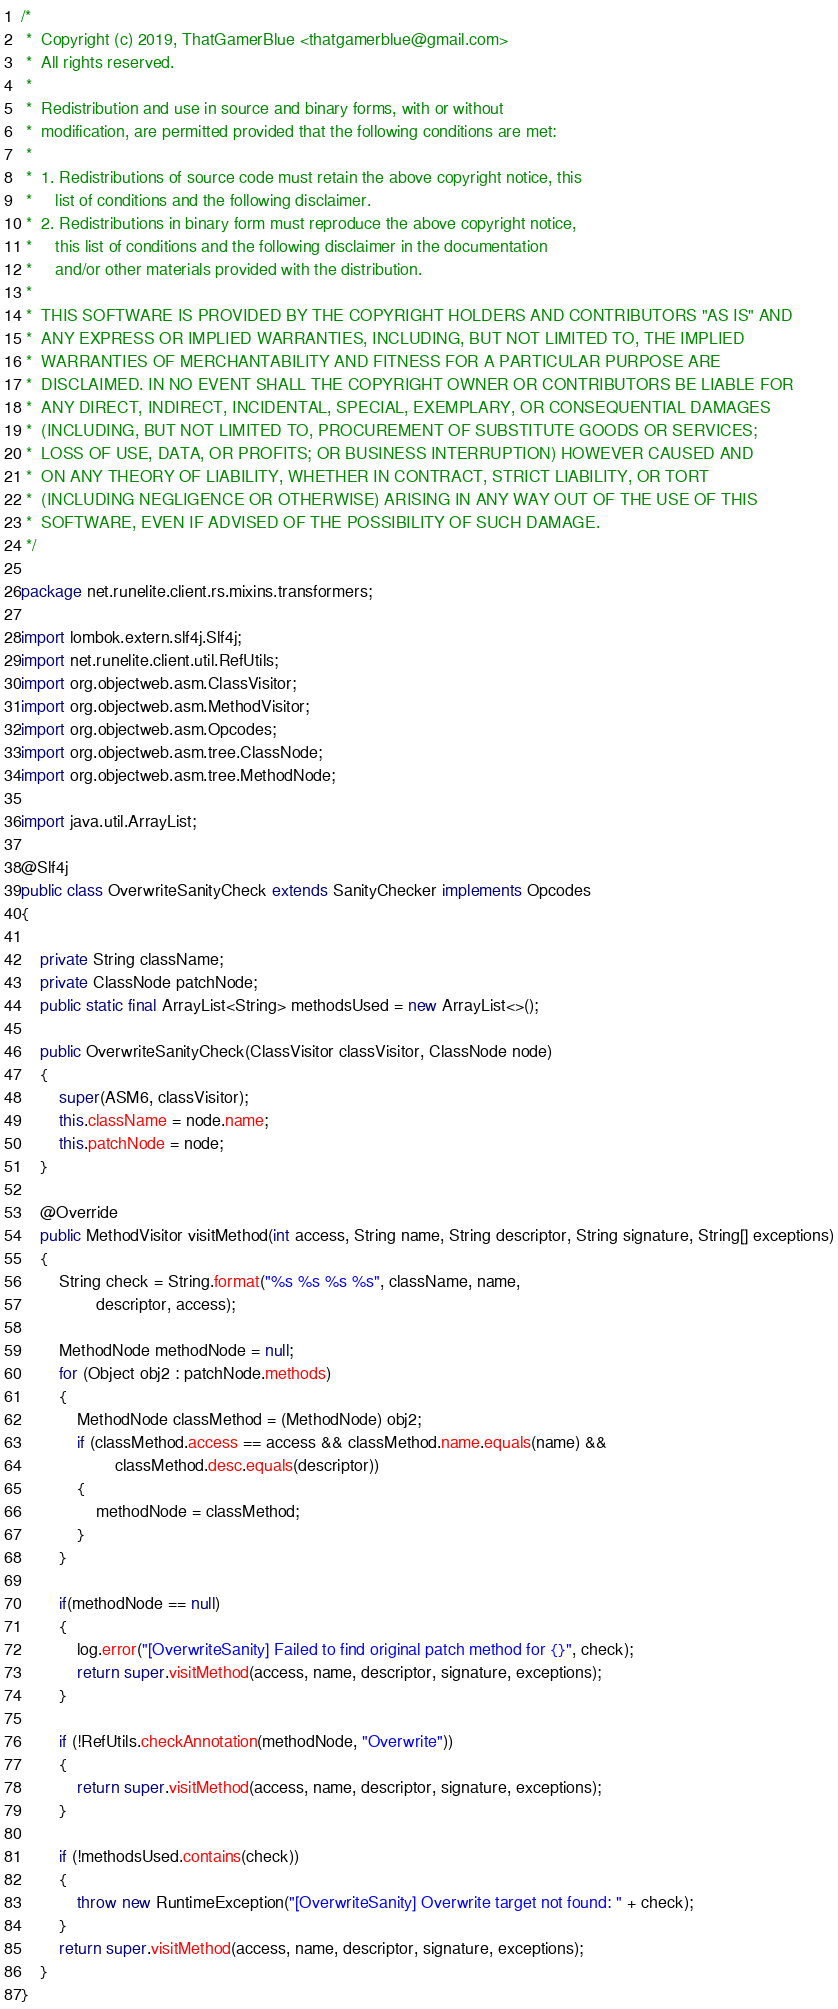Convert code to text. <code><loc_0><loc_0><loc_500><loc_500><_Java_>/*
 *  Copyright (c) 2019, ThatGamerBlue <thatgamerblue@gmail.com>
 *  All rights reserved.
 *
 *  Redistribution and use in source and binary forms, with or without
 *  modification, are permitted provided that the following conditions are met:
 *
 *  1. Redistributions of source code must retain the above copyright notice, this
 *     list of conditions and the following disclaimer.
 *  2. Redistributions in binary form must reproduce the above copyright notice,
 *     this list of conditions and the following disclaimer in the documentation
 *     and/or other materials provided with the distribution.
 *
 *  THIS SOFTWARE IS PROVIDED BY THE COPYRIGHT HOLDERS AND CONTRIBUTORS "AS IS" AND
 *  ANY EXPRESS OR IMPLIED WARRANTIES, INCLUDING, BUT NOT LIMITED TO, THE IMPLIED
 *  WARRANTIES OF MERCHANTABILITY AND FITNESS FOR A PARTICULAR PURPOSE ARE
 *  DISCLAIMED. IN NO EVENT SHALL THE COPYRIGHT OWNER OR CONTRIBUTORS BE LIABLE FOR
 *  ANY DIRECT, INDIRECT, INCIDENTAL, SPECIAL, EXEMPLARY, OR CONSEQUENTIAL DAMAGES
 *  (INCLUDING, BUT NOT LIMITED TO, PROCUREMENT OF SUBSTITUTE GOODS OR SERVICES;
 *  LOSS OF USE, DATA, OR PROFITS; OR BUSINESS INTERRUPTION) HOWEVER CAUSED AND
 *  ON ANY THEORY OF LIABILITY, WHETHER IN CONTRACT, STRICT LIABILITY, OR TORT
 *  (INCLUDING NEGLIGENCE OR OTHERWISE) ARISING IN ANY WAY OUT OF THE USE OF THIS
 *  SOFTWARE, EVEN IF ADVISED OF THE POSSIBILITY OF SUCH DAMAGE.
 */

package net.runelite.client.rs.mixins.transformers;

import lombok.extern.slf4j.Slf4j;
import net.runelite.client.util.RefUtils;
import org.objectweb.asm.ClassVisitor;
import org.objectweb.asm.MethodVisitor;
import org.objectweb.asm.Opcodes;
import org.objectweb.asm.tree.ClassNode;
import org.objectweb.asm.tree.MethodNode;

import java.util.ArrayList;

@Slf4j
public class OverwriteSanityCheck extends SanityChecker implements Opcodes
{
	
	private String className;
	private ClassNode patchNode;
	public static final ArrayList<String> methodsUsed = new ArrayList<>();
	
	public OverwriteSanityCheck(ClassVisitor classVisitor, ClassNode node)
	{
		super(ASM6, classVisitor);
		this.className = node.name;
		this.patchNode = node;
	}
	
	@Override
	public MethodVisitor visitMethod(int access, String name, String descriptor, String signature, String[] exceptions)
	{
		String check = String.format("%s %s %s %s", className, name,
				descriptor, access);
		
		MethodNode methodNode = null;
		for (Object obj2 : patchNode.methods)
		{
			MethodNode classMethod = (MethodNode) obj2;
			if (classMethod.access == access && classMethod.name.equals(name) &&
					classMethod.desc.equals(descriptor))
			{
				methodNode = classMethod;
			}
		}
		
		if(methodNode == null)
		{
			log.error("[OverwriteSanity] Failed to find original patch method for {}", check);
			return super.visitMethod(access, name, descriptor, signature, exceptions);
		}
		
		if (!RefUtils.checkAnnotation(methodNode, "Overwrite"))
		{
			return super.visitMethod(access, name, descriptor, signature, exceptions);
		}
		
		if (!methodsUsed.contains(check))
		{
			throw new RuntimeException("[OverwriteSanity] Overwrite target not found: " + check);
		}
		return super.visitMethod(access, name, descriptor, signature, exceptions);
	}
}
</code> 